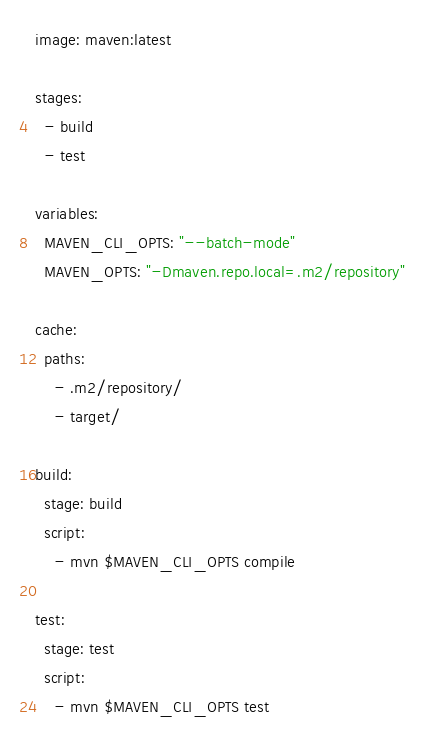Convert code to text. <code><loc_0><loc_0><loc_500><loc_500><_YAML_>image: maven:latest

stages:
  - build
  - test

variables:
  MAVEN_CLI_OPTS: "--batch-mode"
  MAVEN_OPTS: "-Dmaven.repo.local=.m2/repository"

cache:
  paths:
    - .m2/repository/
    - target/

build:
  stage: build
  script:
    - mvn $MAVEN_CLI_OPTS compile

test:
  stage: test
  script:
    - mvn $MAVEN_CLI_OPTS test
</code> 